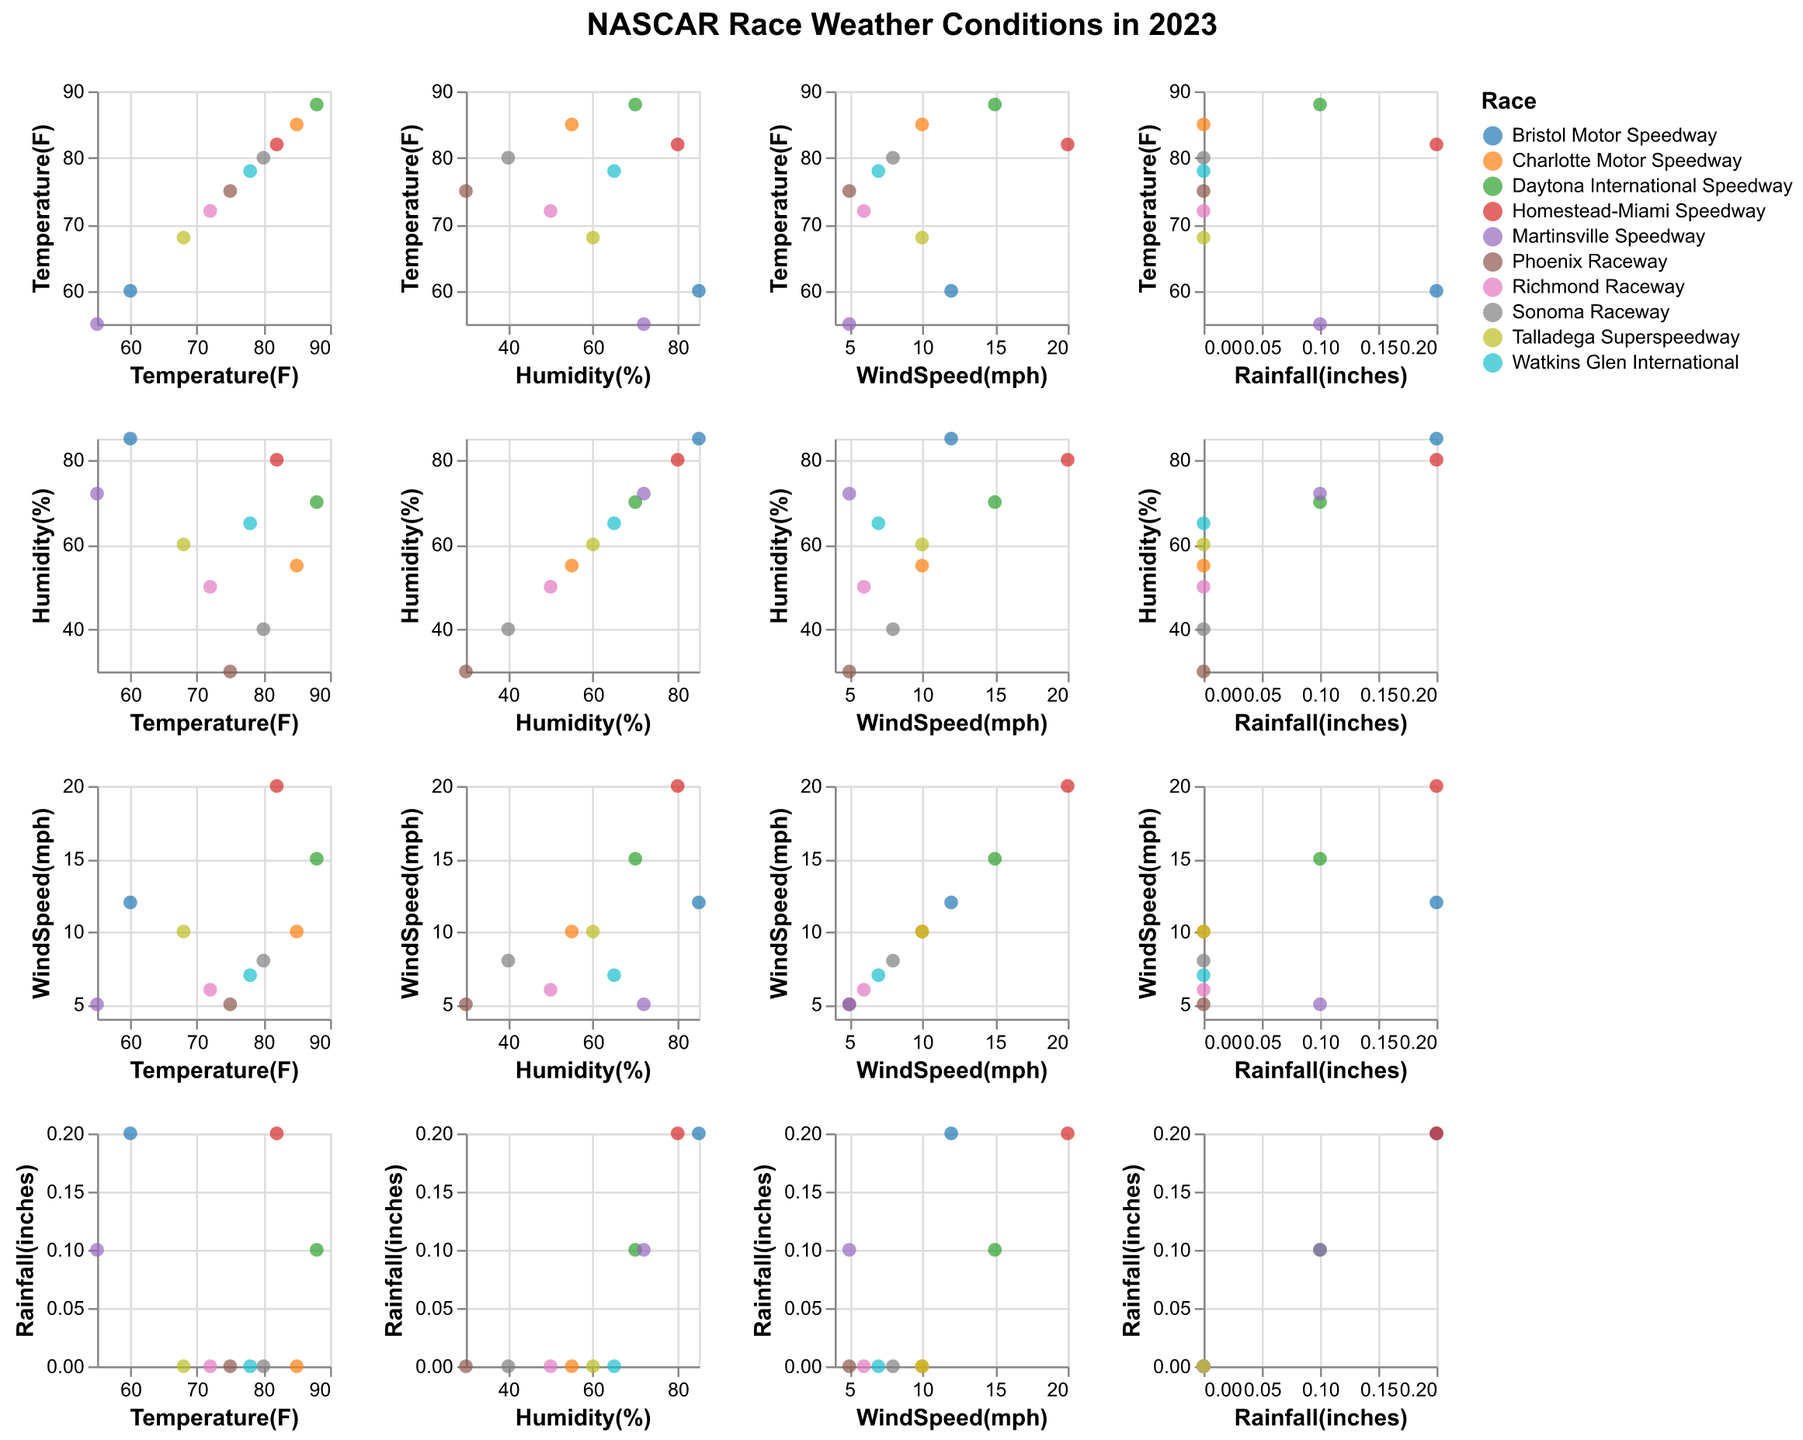What's the title of the figure? The title is written at the top center of the figure.
Answer: NASCAR Race Weather Conditions in 2023 How many different racetracks are represented in this figure? Each data point in the scatter plots is colored differently according to the racetrack. By counting the legend entries or the tooltip information, you can identify the number.
Answer: 10 Which racetrack had the highest temperature recorded? Identify the data point with the highest temperature value on the x-axis of the Temperature vs. Temperature plot and check its tooltip information.
Answer: Daytona International Speedway (88°F) Does higher humidity correlate with higher rainfall? Observe the pattern in the Humidity vs. Rainfall scatter plot. Look if points are more concentrated towards higher values on both axes.
Answer: Yes, there is a visible pattern of higher humidity correlating with higher rainfall Is there any race that experienced rainfall but low humidity? Find any data points in the Rainfall vs. Humidity plot with non-zero rainfall values but lower humidity percentages.
Answer: No Which two races had the same wind speed but different rainfall amounts? Identify data points in the WindSpeed vs. Rainfall plot that align vertically but at different positions on the y-axis. Cross-reference these points using their tooltips.
Answer: Bristol Motor Speedway and Martinsville Speedway What is the average temperature of all races held at an elevation below 70% humidity? Identify the data points in the Temperature vs. Humidity plot with humidity below 70%, sum their temperature values, and divide by the count of those data points.
Answer: (75 + 80 + 72 + 68) / 4 = 73.75°F Which race had the lowest wind speed, and what was its rainfall? Locate the data point with the lowest wind speed on the y-axis of the WindSpeed vs. Rainfall plot and check its tooltip for rainfall information.
Answer: Phoenix Raceway, 0.0 inches How does wind speed generally affect temperature across the races? Look for any trend or pattern in the WindSpeed vs. Temperature scatter plot, such as an upward or downward trend.
Answer: Higher wind speed does not show a clear pattern of affecting temperature Are there more races that occurred with zero rainfall or with some amount of rainfall? Count the data points with zero rainfall and non-zero rainfall in the Rainfall axis of the Rainfall vs. all other parameters plots.
Answer: More races occurred with zero rainfall 